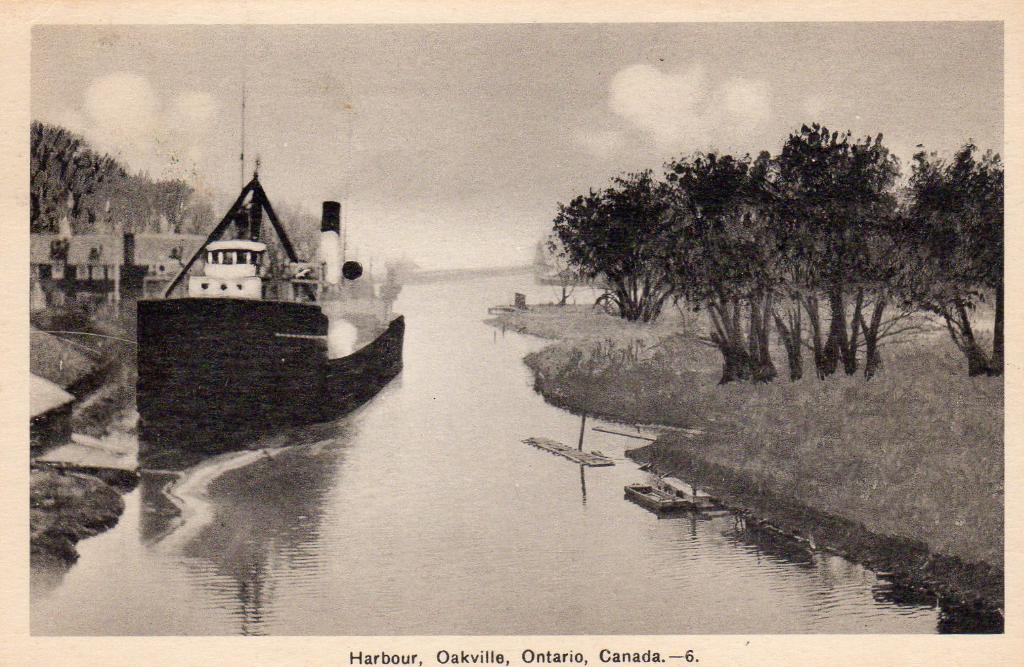What country is this photo?
Offer a very short reply. Canada. What province is this picture from?
Make the answer very short. Ontario. 